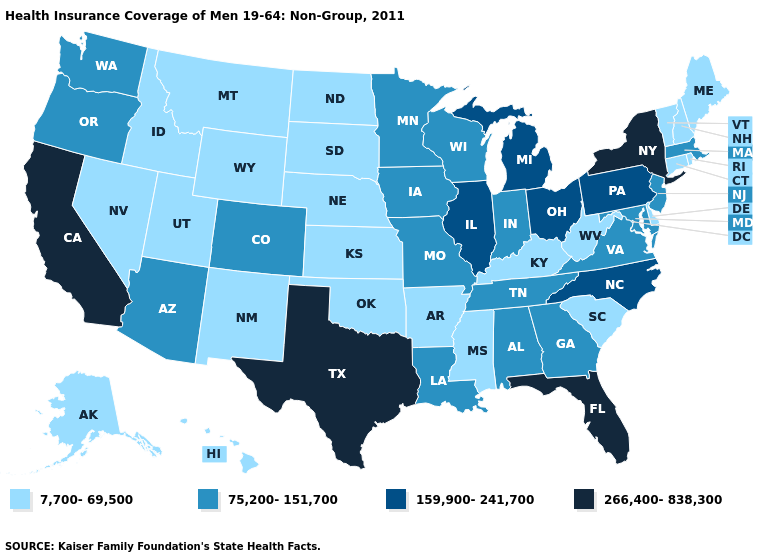Name the states that have a value in the range 7,700-69,500?
Write a very short answer. Alaska, Arkansas, Connecticut, Delaware, Hawaii, Idaho, Kansas, Kentucky, Maine, Mississippi, Montana, Nebraska, Nevada, New Hampshire, New Mexico, North Dakota, Oklahoma, Rhode Island, South Carolina, South Dakota, Utah, Vermont, West Virginia, Wyoming. Is the legend a continuous bar?
Answer briefly. No. What is the value of Pennsylvania?
Short answer required. 159,900-241,700. Does Missouri have the lowest value in the USA?
Keep it brief. No. What is the value of Rhode Island?
Quick response, please. 7,700-69,500. What is the lowest value in states that border Georgia?
Write a very short answer. 7,700-69,500. Among the states that border Massachusetts , which have the highest value?
Give a very brief answer. New York. Is the legend a continuous bar?
Quick response, please. No. Does Arkansas have the lowest value in the USA?
Concise answer only. Yes. What is the highest value in the USA?
Give a very brief answer. 266,400-838,300. What is the value of New Jersey?
Short answer required. 75,200-151,700. What is the value of North Carolina?
Quick response, please. 159,900-241,700. What is the value of New Jersey?
Be succinct. 75,200-151,700. Name the states that have a value in the range 159,900-241,700?
Be succinct. Illinois, Michigan, North Carolina, Ohio, Pennsylvania. 